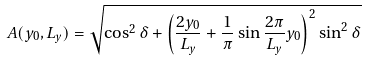Convert formula to latex. <formula><loc_0><loc_0><loc_500><loc_500>A ( y _ { 0 } , L _ { y } ) = \sqrt { \cos ^ { 2 } \delta + \left ( \frac { 2 y _ { 0 } } { L _ { y } } + \frac { 1 } { \pi } \sin \frac { 2 \pi } { L _ { y } } y _ { 0 } \right ) ^ { 2 } \sin ^ { 2 } \delta }</formula> 